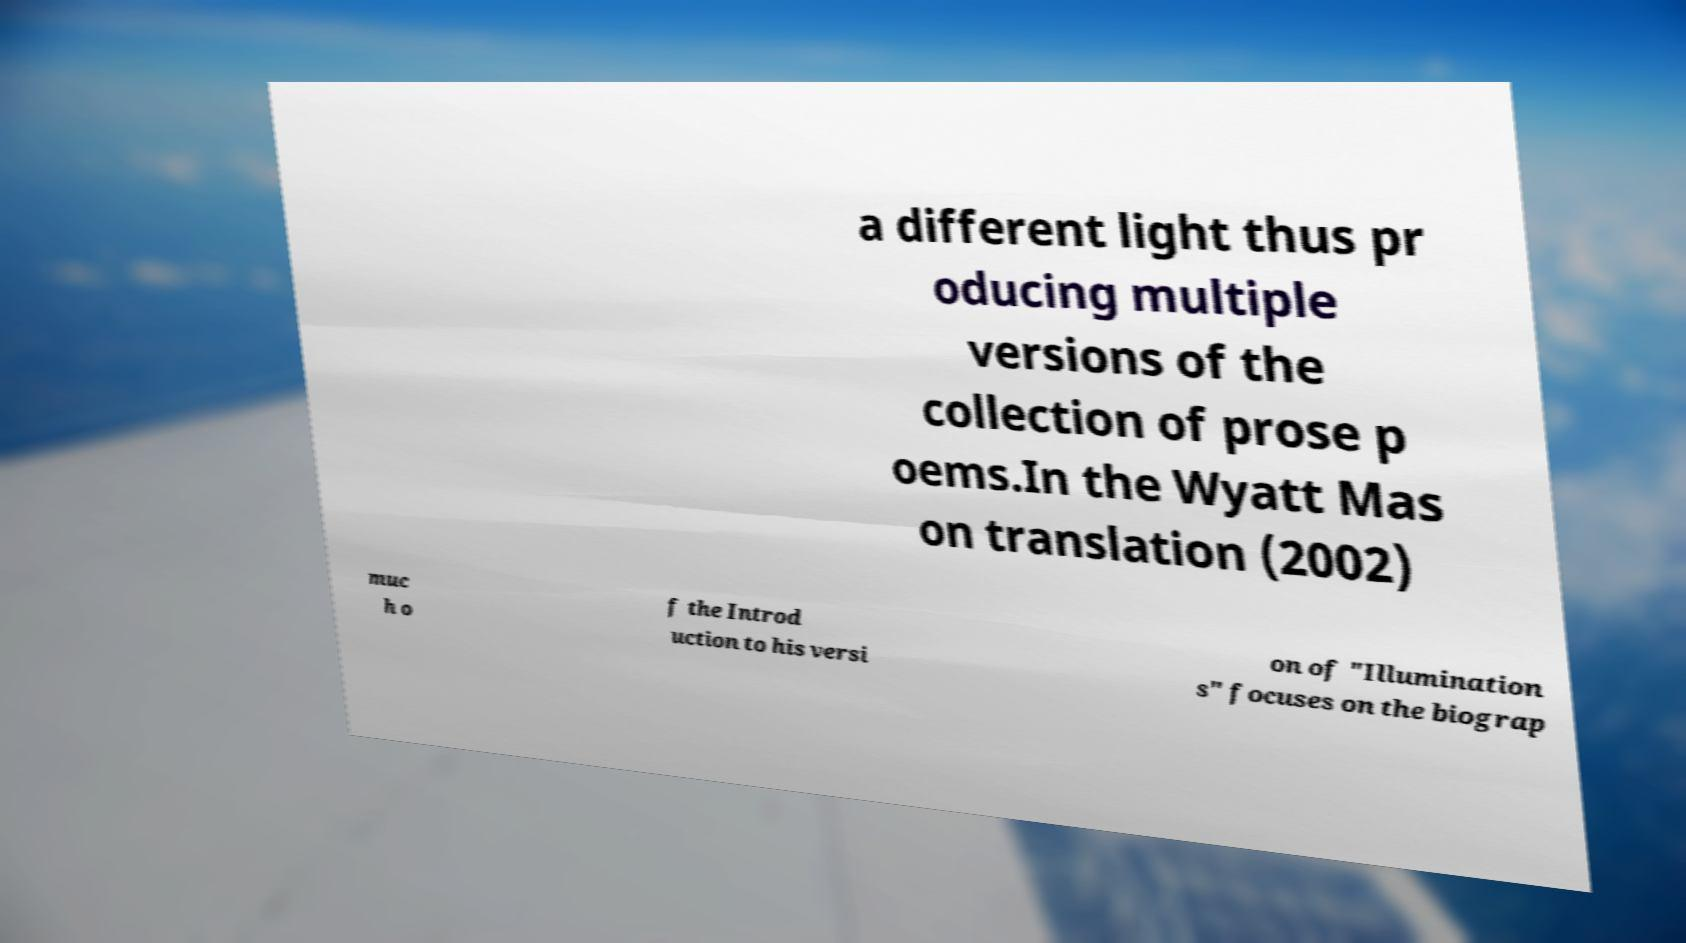Please read and relay the text visible in this image. What does it say? a different light thus pr oducing multiple versions of the collection of prose p oems.In the Wyatt Mas on translation (2002) muc h o f the Introd uction to his versi on of "Illumination s" focuses on the biograp 